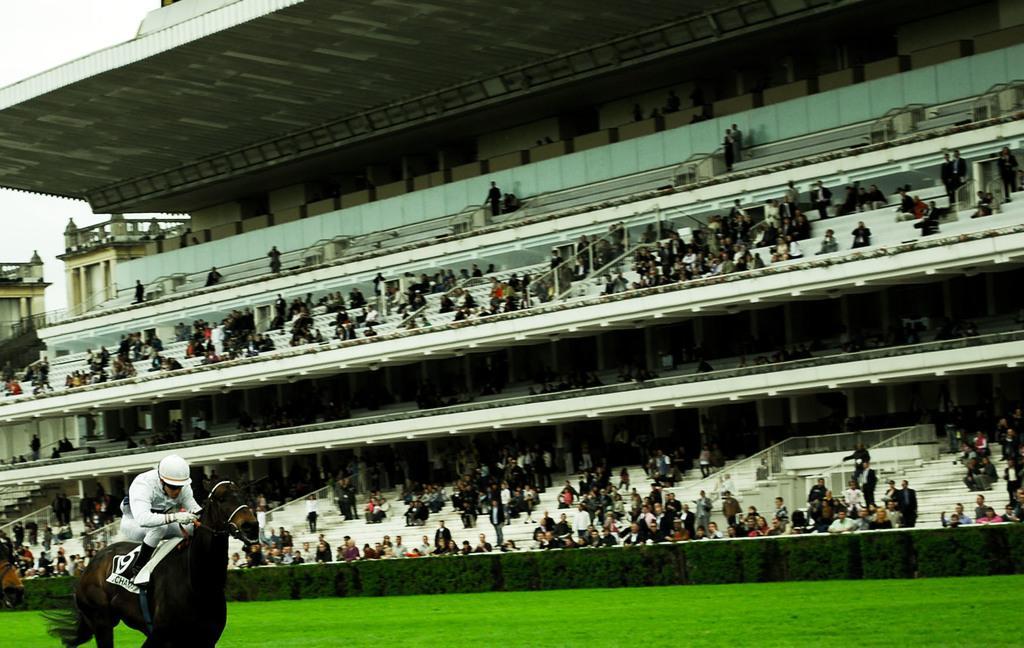How would you summarize this image in a sentence or two? In this picture we can see a person riding a horse, this person wore a helmet, at the bottom there is grass, we can see some people sitting here, there are some stairs here, we can see the sky at the left top of the picture. 